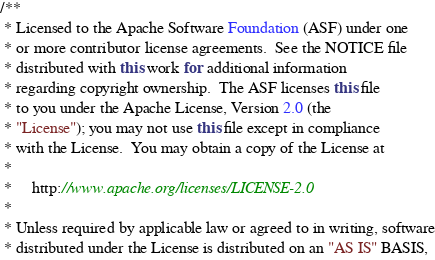<code> <loc_0><loc_0><loc_500><loc_500><_Java_>/**
 * Licensed to the Apache Software Foundation (ASF) under one
 * or more contributor license agreements.  See the NOTICE file
 * distributed with this work for additional information
 * regarding copyright ownership.  The ASF licenses this file
 * to you under the Apache License, Version 2.0 (the
 * "License"); you may not use this file except in compliance
 * with the License.  You may obtain a copy of the License at
 *
 *     http://www.apache.org/licenses/LICENSE-2.0
 *
 * Unless required by applicable law or agreed to in writing, software
 * distributed under the License is distributed on an "AS IS" BASIS,</code> 